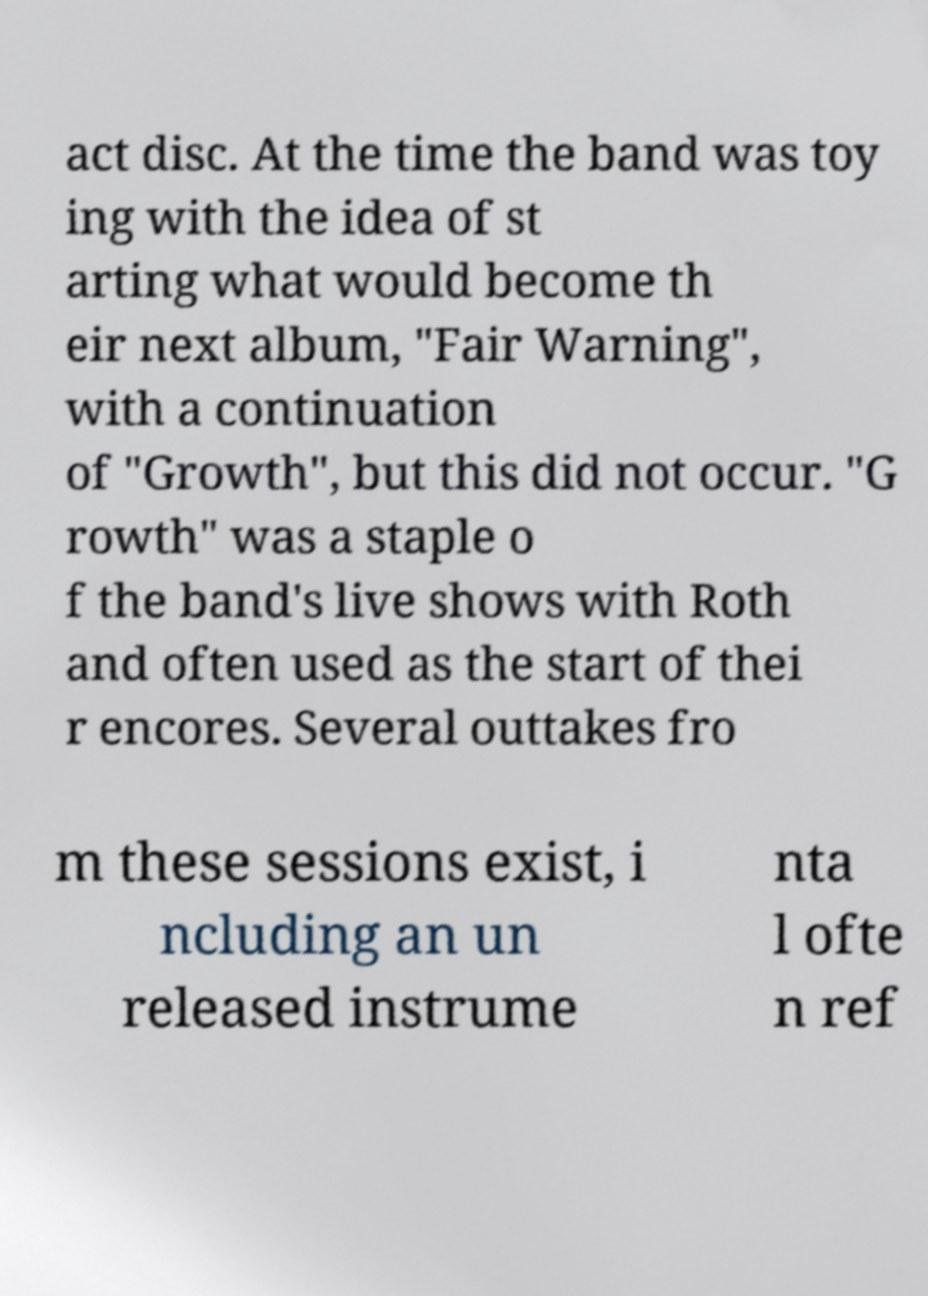Please read and relay the text visible in this image. What does it say? act disc. At the time the band was toy ing with the idea of st arting what would become th eir next album, "Fair Warning", with a continuation of "Growth", but this did not occur. "G rowth" was a staple o f the band's live shows with Roth and often used as the start of thei r encores. Several outtakes fro m these sessions exist, i ncluding an un released instrume nta l ofte n ref 